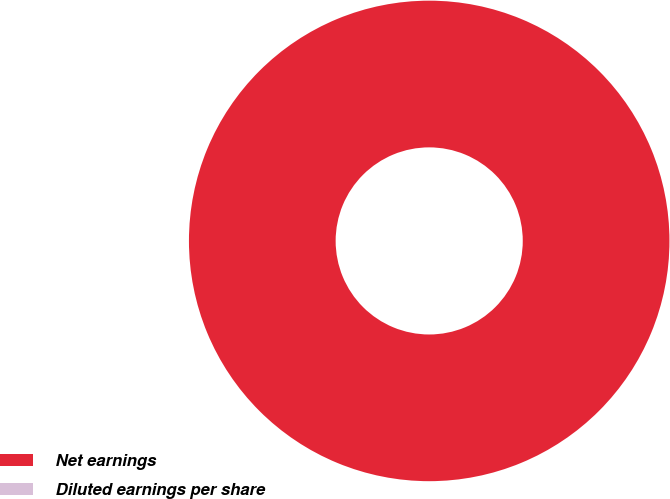Convert chart to OTSL. <chart><loc_0><loc_0><loc_500><loc_500><pie_chart><fcel>Net earnings<fcel>Diluted earnings per share<nl><fcel>100.0%<fcel>0.0%<nl></chart> 